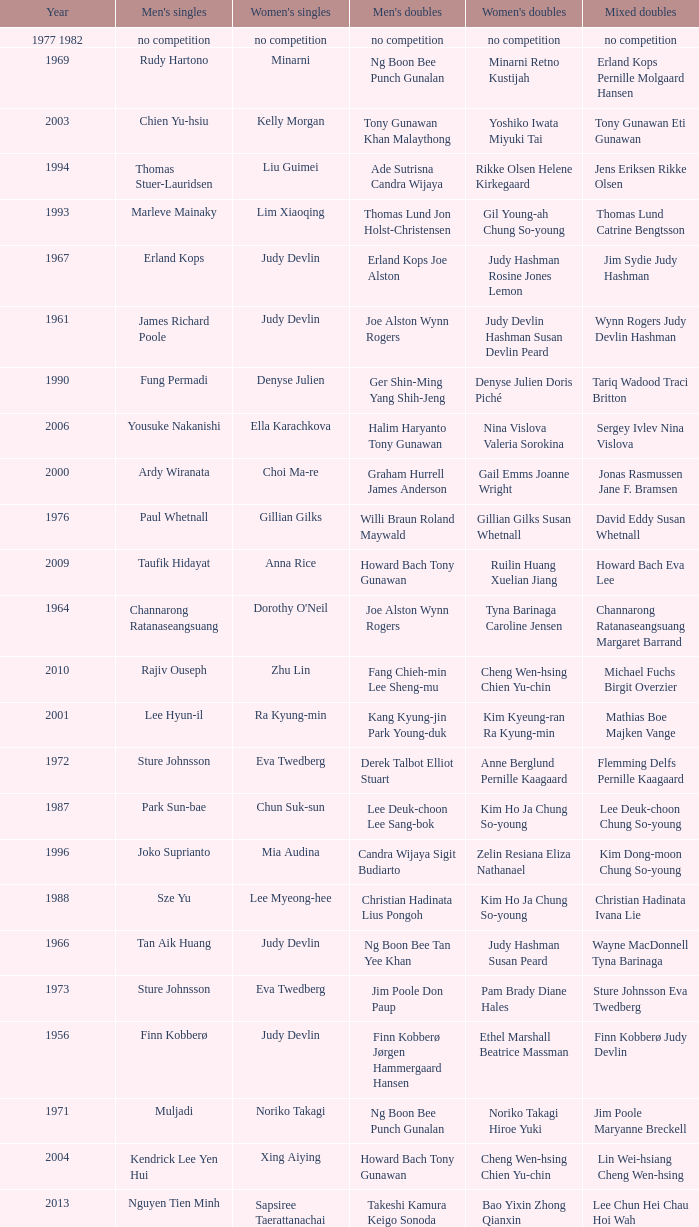Who were the men's doubles champions when the men's singles champion was muljadi? Ng Boon Bee Punch Gunalan. 